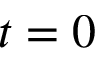<formula> <loc_0><loc_0><loc_500><loc_500>t = 0</formula> 